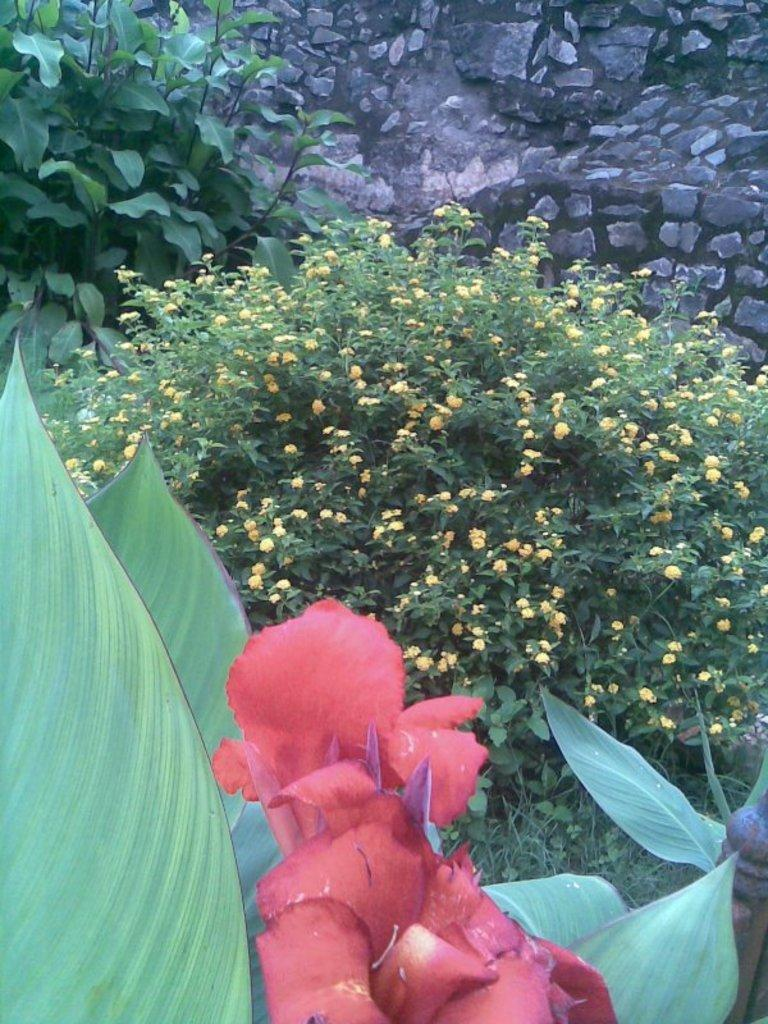What type of flowers can be seen on the plant in the image? There are red color flowers on a plant in the image. What type of vegetation is visible in the image besides the flowers? There is grass visible in the image, as well as small plants. What can be seen in the background of the image? There is a stone wall in the background of the image. Who is wearing a crown while reading a book in the image? There is no person wearing a crown or reading a book in the image; it features flowers, grass, small plants, and a stone wall. 